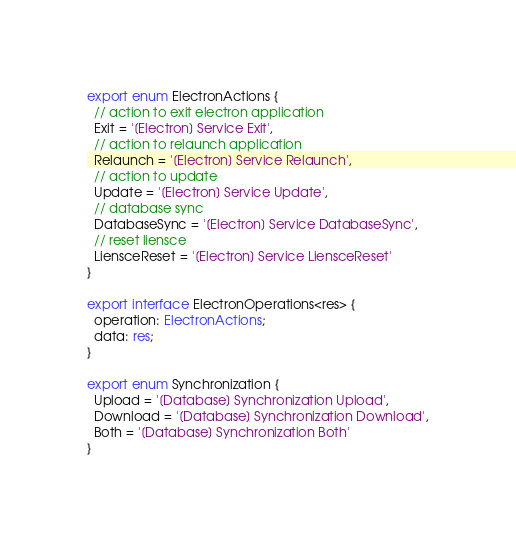Convert code to text. <code><loc_0><loc_0><loc_500><loc_500><_TypeScript_>export enum ElectronActions {
  // action to exit electron application
  Exit = '[Electron] Service Exit',
  // action to relaunch application
  Relaunch = '[Electron] Service Relaunch',
  // action to update
  Update = '[Electron] Service Update',
  // database sync
  DatabaseSync = '[Electron] Service DatabaseSync',
  // reset liensce
  LiensceReset = '[Electron] Service LiensceReset'
}

export interface ElectronOperations<res> {
  operation: ElectronActions;
  data: res;
}

export enum Synchronization {
  Upload = '[Database] Synchronization Upload',
  Download = '[Database] Synchronization Download',
  Both = '[Database] Synchronization Both'
}
</code> 